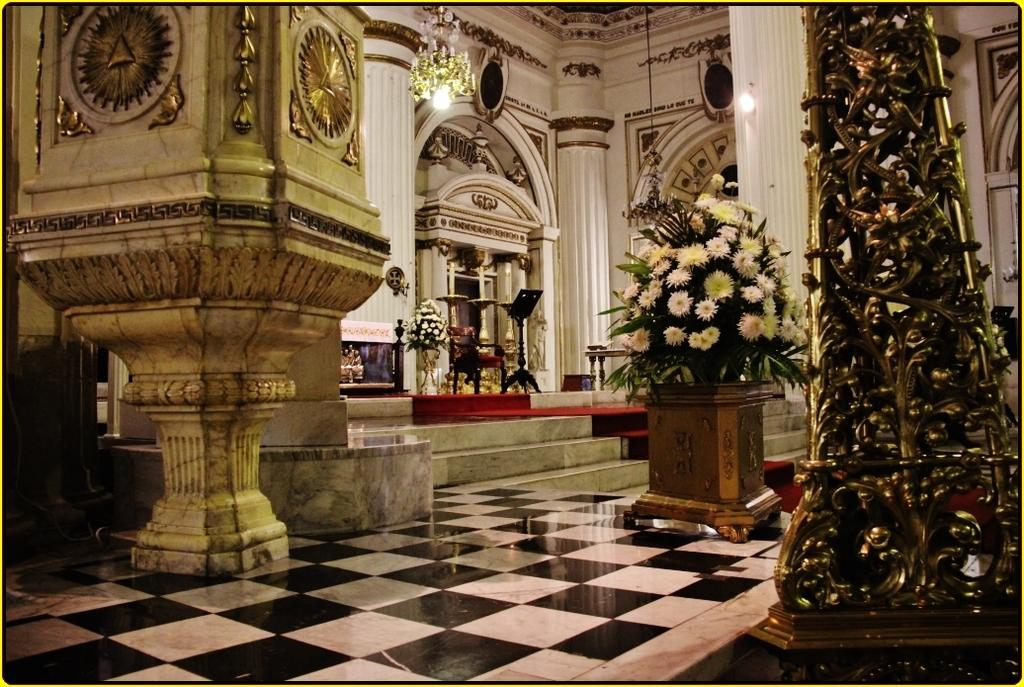What is the perspective of the image? The image is taken from inside. What architectural features can be seen in the image? There are pillars with designs, arches, and a wall of a building visible in the image. What type of decorative objects are present in the image? Flower pots and a chandelier are present in the image. What type of furniture is visible in the image? There is a chair in the image. How many objects can be seen in the image? There are a few objects in the image. What type of winter clothing is the visitor wearing in the image? There is no visitor present in the image, and therefore no winter clothing can be observed. How many bananas are hanging from the chandelier in the image? There are no bananas present in the image, and therefore none can be seen hanging from the chandelier. 